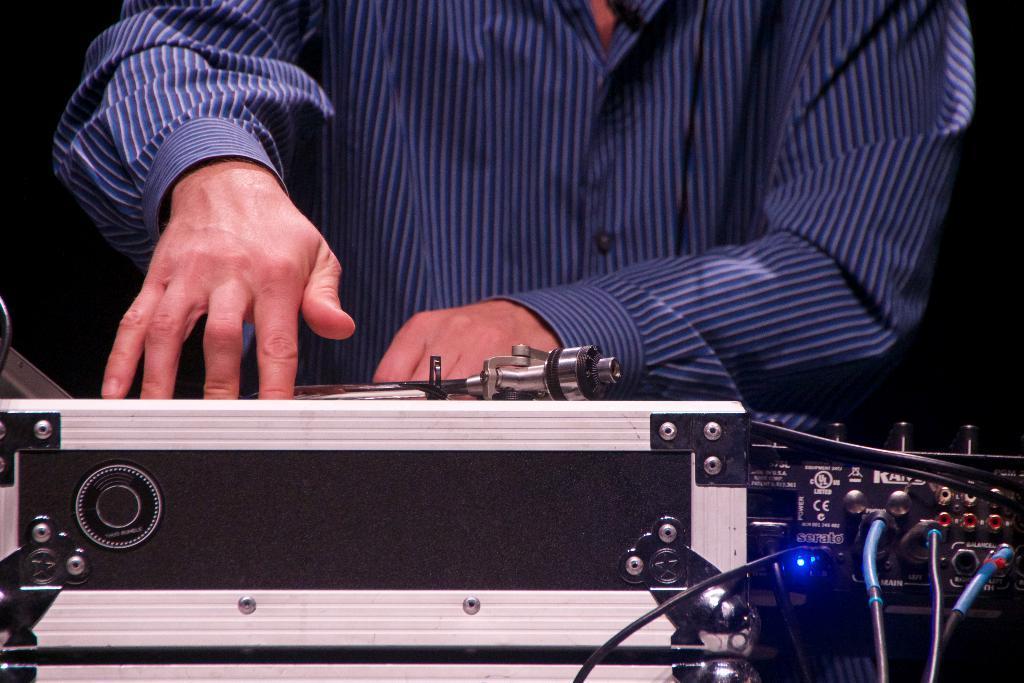Describe this image in one or two sentences. In this picture we can see the hands of a person on an object. We can see a few wires and an electronic device on the right side. Background is black in color. 